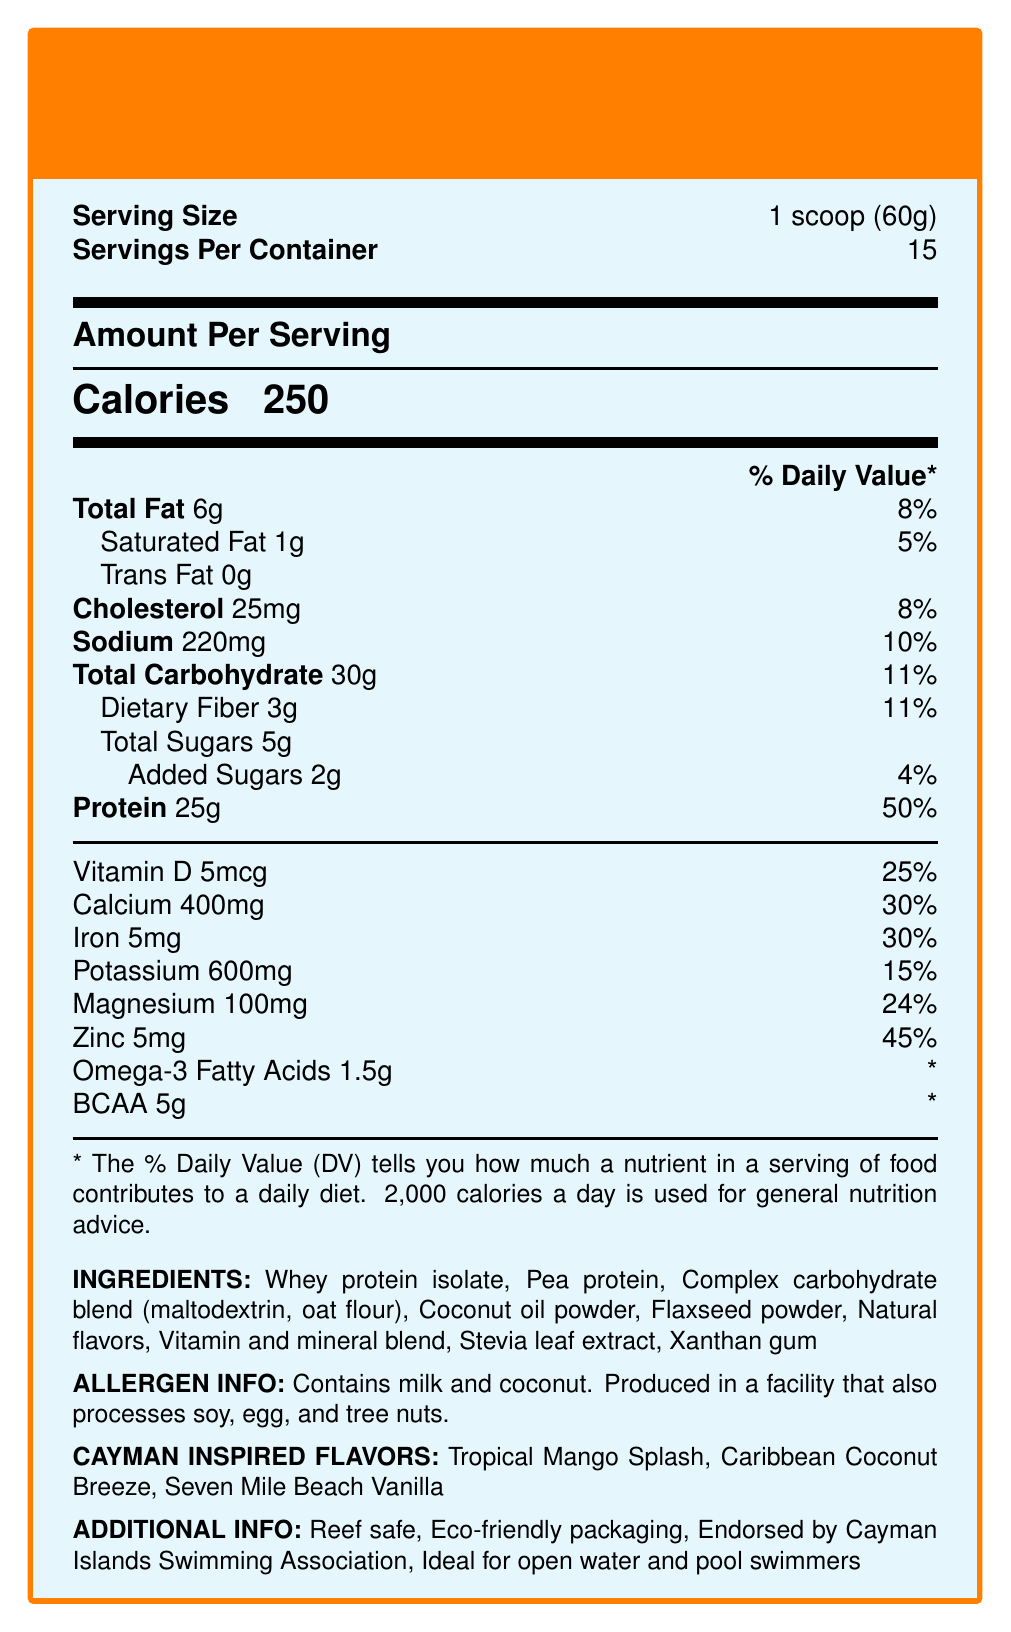What is the serving size for SwimFuel Pro: Cayman Splash Edition? The document states that the serving size is '1 scoop (60g)'.
Answer: 1 scoop (60g) How many calories are there per serving? The 'Calories' section lists 250 calories per serving.
Answer: 250 What percentage of the daily value for protein does one serving contain? The document shows that a serving contains 25g of protein, which is 50% of the daily value.
Answer: 50% Which vitamins or minerals does SwimFuel Pro provide in a daily value over 20%? Vitamin D is 25%, Calcium is 30%, Iron is 30%, Magnesium is 24%, and Zinc is 45% according to the document.
Answer: Vitamin D, Calcium, Iron, Magnesium, Zinc What allergens are present in SwimFuel Pro? The allergen information section states that it contains milk and coconut.
Answer: Milk and coconut Which flavors are inspired by the Cayman Islands? (Options: A. Berry Blast, B. Tropical Mango Splash, C. Caribbean Coconut Breeze, D. Seven Mile Beach Vanilla) The Cayman-inspired flavors listed are "Tropical Mango Splash," "Caribbean Coconut Breeze," and "Seven Mile Beach Vanilla."
Answer: B, C, D What is the Protein content per serving? (Options: i. 20g, ii. 25g, iii. 30g, iv. 15g) The document lists the protein content as 25g per serving.
Answer: ii. 25g Is SwimFuel Pro suitable for pool swimmers? The additional information states that it is ideal for open water and pool swimmers.
Answer: Yes Is the packaging of SwimFuel Pro eco-friendly? The additional information section mentions that the packaging is eco-friendly.
Answer: Yes Provide a brief summary of the nutritional profile and additional details about SwimFuel Pro: Cayman Splash Edition. The summary covers the most critical points, including nutritional values, flavors, and additional endorsements and benefits.
Answer: SwimFuel Pro: Cayman Splash Edition is a nutrient-dense meal replacement shake designed for competitive swimmers. Each 60g serving provides 250 calories with 25g of protein (50% DV), 6g of total fat (8% DV), 30g of carbs (11% DV), and various vitamins and minerals such as Vitamin D (25% DV), Calcium (30% DV), and Zinc (45% DV). It is offered in Cayman-inspired flavors like Tropical Mango Splash and is endorsed by the Cayman Islands Swimming Association. The product is reef safe and features eco-friendly packaging. Does SwimFuel Pro contain any soy ingredients? The document only states it is produced in a facility that also processes soy, but does not confirm if soy is an ingredient in SwimFuel Pro.
Answer: Cannot be determined How much dietary fiber is in one serving of SwimFuel Pro? The total dietary fiber content per serving is listed as 3g with an 11% daily value.
Answer: 3g 